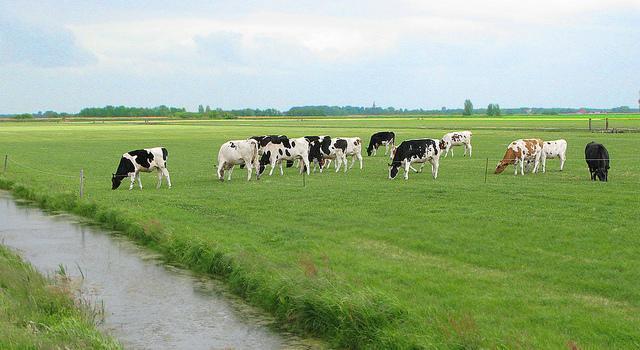How many cows are shown?
Give a very brief answer. 12. How many people are dressed in green?
Give a very brief answer. 0. 